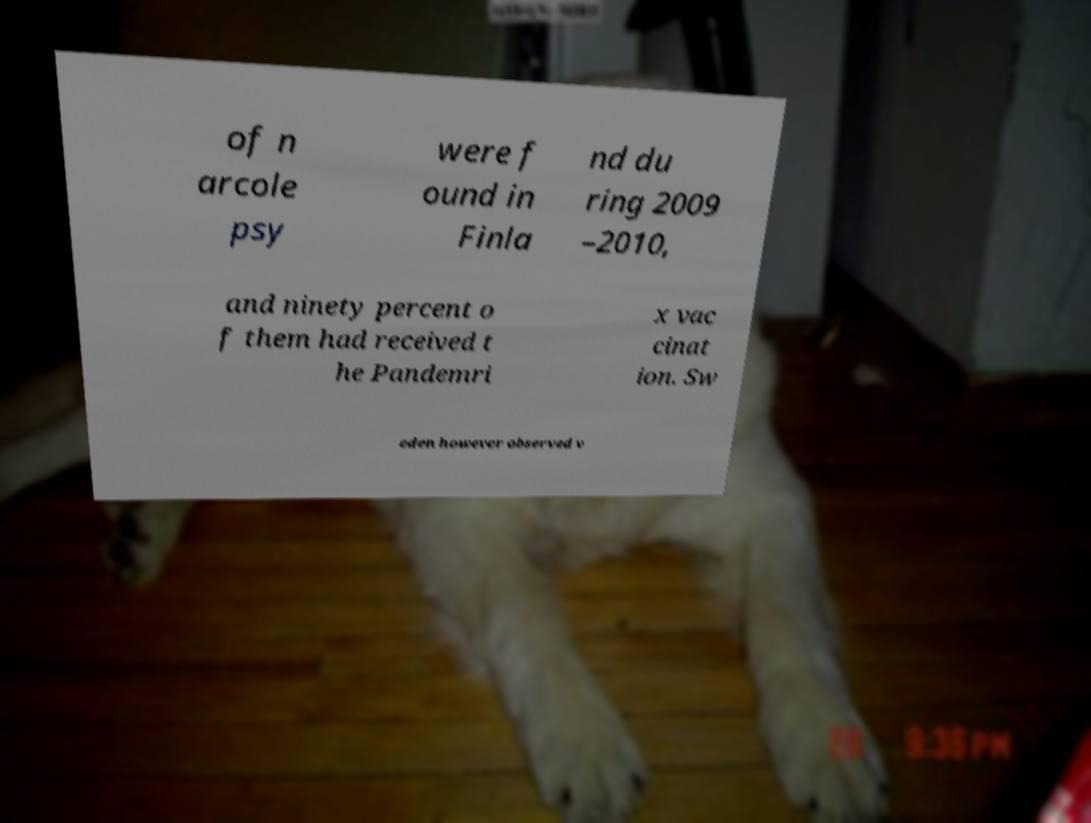For documentation purposes, I need the text within this image transcribed. Could you provide that? of n arcole psy were f ound in Finla nd du ring 2009 –2010, and ninety percent o f them had received t he Pandemri x vac cinat ion. Sw eden however observed v 